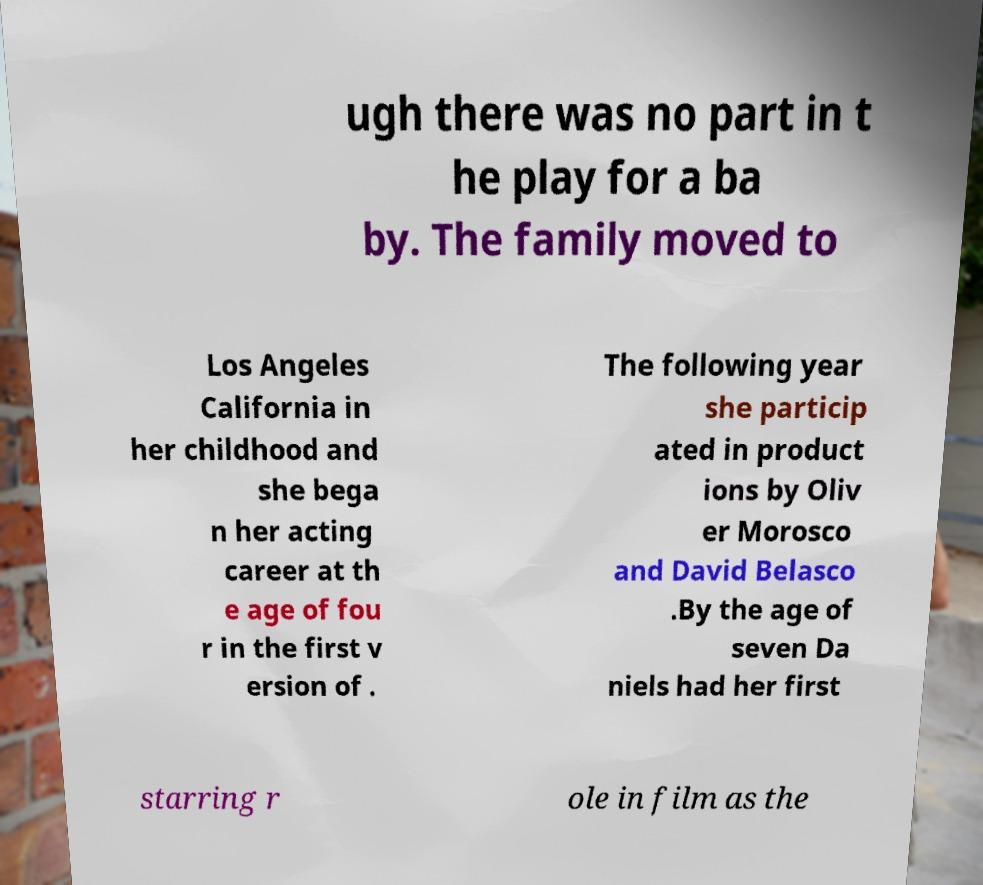What messages or text are displayed in this image? I need them in a readable, typed format. ugh there was no part in t he play for a ba by. The family moved to Los Angeles California in her childhood and she bega n her acting career at th e age of fou r in the first v ersion of . The following year she particip ated in product ions by Oliv er Morosco and David Belasco .By the age of seven Da niels had her first starring r ole in film as the 